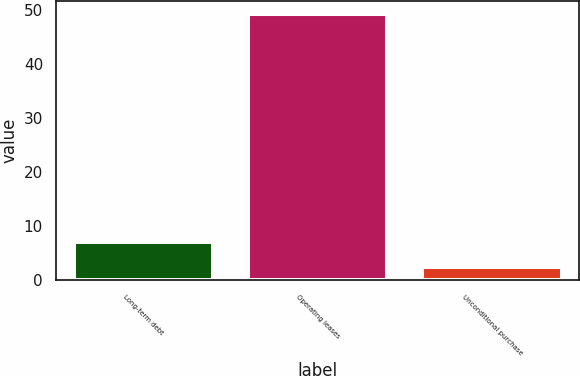<chart> <loc_0><loc_0><loc_500><loc_500><bar_chart><fcel>Long-term debt<fcel>Operating leases<fcel>Unconditional purchase<nl><fcel>7.15<fcel>49.3<fcel>2.47<nl></chart> 